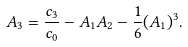<formula> <loc_0><loc_0><loc_500><loc_500>A _ { 3 } = \frac { c _ { 3 } } { c _ { 0 } } - A _ { 1 } A _ { 2 } - \frac { 1 } { 6 } ( A _ { 1 } ) ^ { 3 } .</formula> 